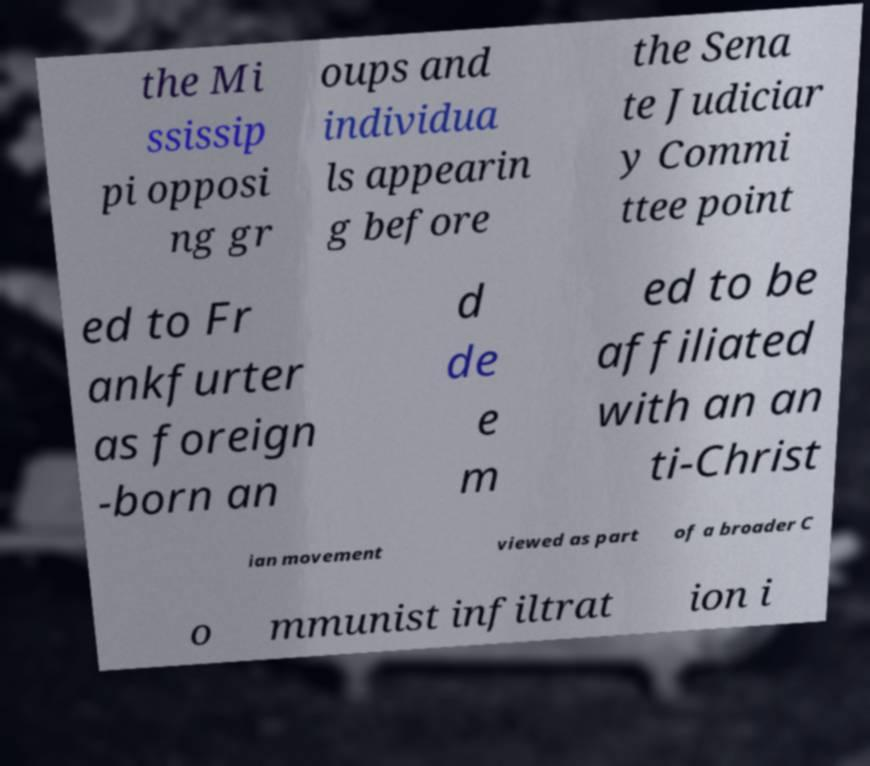For documentation purposes, I need the text within this image transcribed. Could you provide that? the Mi ssissip pi opposi ng gr oups and individua ls appearin g before the Sena te Judiciar y Commi ttee point ed to Fr ankfurter as foreign -born an d de e m ed to be affiliated with an an ti-Christ ian movement viewed as part of a broader C o mmunist infiltrat ion i 